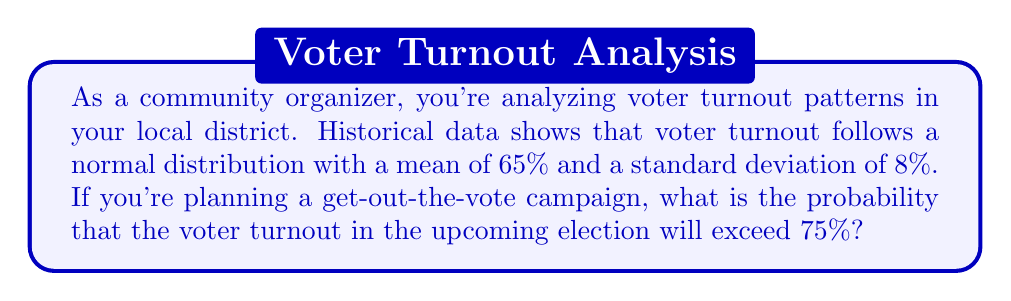Could you help me with this problem? To solve this problem, we'll use the properties of the normal distribution and the concept of z-scores.

Step 1: Identify the given information
- Voter turnout follows a normal distribution
- Mean (μ) = 65%
- Standard deviation (σ) = 8%
- We want to find P(X > 75%), where X is the voter turnout

Step 2: Calculate the z-score for 75% turnout
The z-score formula is: $z = \frac{x - \mu}{\sigma}$

Plugging in our values:
$z = \frac{75 - 65}{8} = \frac{10}{8} = 1.25$

Step 3: Use the standard normal distribution table or calculator
We need to find P(Z > 1.25), which is the area to the right of z = 1.25 on the standard normal distribution.

Using a standard normal distribution table or calculator, we find:
P(Z > 1.25) ≈ 0.1056

Step 4: Interpret the result
The probability that voter turnout will exceed 75% is approximately 0.1056 or 10.56%.

This information can help you as a community organizer to set realistic goals for your get-out-the-vote campaign and allocate resources effectively.
Answer: 0.1056 